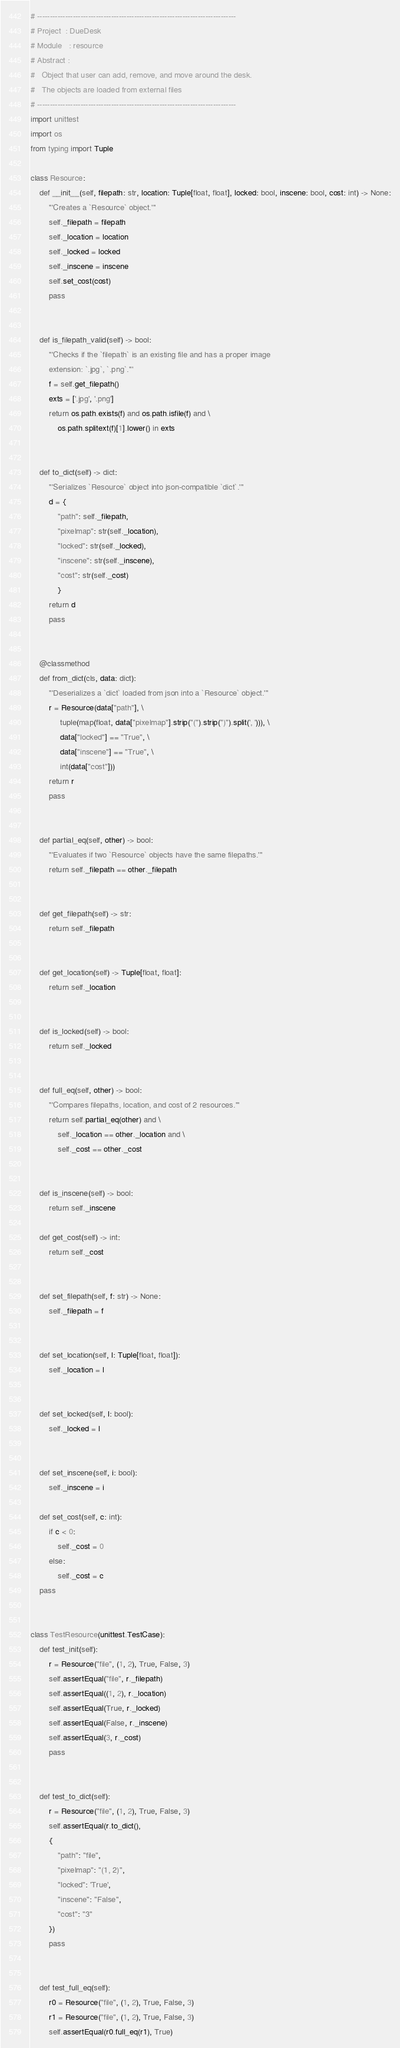<code> <loc_0><loc_0><loc_500><loc_500><_Python_># ------------------------------------------------------------------------------
# Project  : DueDesk
# Module   : resource
# Abstract : 
#   Object that user can add, remove, and move around the desk.
#   The objects are loaded from external files
# ------------------------------------------------------------------------------
import unittest
import os
from typing import Tuple

class Resource:
    def __init__(self, filepath: str, location: Tuple[float, float], locked: bool, inscene: bool, cost: int) -> None:
        '''Creates a `Resource` object.'''
        self._filepath = filepath
        self._location = location
        self._locked = locked
        self._inscene = inscene
        self.set_cost(cost)
        pass


    def is_filepath_valid(self) -> bool:
        '''Checks if the `filepath` is an existing file and has a proper image 
        extension: `.jpg`, `.png`.'''
        f = self.get_filepath()
        exts = ['.jpg', '.png']
        return os.path.exists(f) and os.path.isfile(f) and \
            os.path.splitext(f)[1].lower() in exts


    def to_dict(self) -> dict:
        '''Serializes `Resource` object into json-compatible `dict`.'''
        d = {
            "path": self._filepath, 
            "pixelmap": str(self._location), 
            "locked": str(self._locked), 
            "inscene": str(self._inscene),
            "cost": str(self._cost)
            }
        return d
        pass


    @classmethod
    def from_dict(cls, data: dict):
        '''Deserializes a `dict` loaded from json into a `Resource` object.'''
        r = Resource(data["path"], \
             tuple(map(float, data["pixelmap"].strip("(").strip(")").split(', '))), \
             data["locked"] == "True", \
             data["inscene"] == "True", \
             int(data["cost"]))
        return r
        pass

      
    def partial_eq(self, other) -> bool:
        '''Evaluates if two `Resource` objects have the same filepaths.'''
        return self._filepath == other._filepath
      

    def get_filepath(self) -> str:
        return self._filepath


    def get_location(self) -> Tuple[float, float]:
        return self._location


    def is_locked(self) -> bool:
        return self._locked


    def full_eq(self, other) -> bool:
        '''Compares filepaths, location, and cost of 2 resources.'''
        return self.partial_eq(other) and \
            self._location == other._location and \
            self._cost == other._cost
    

    def is_inscene(self) -> bool:
        return self._inscene

    def get_cost(self) -> int:
        return self._cost


    def set_filepath(self, f: str) -> None:
        self._filepath = f


    def set_location(self, l: Tuple[float, float]):
        self._location = l


    def set_locked(self, l: bool):
        self._locked = l


    def set_inscene(self, i: bool):
        self._inscene = i

    def set_cost(self, c: int):
        if c < 0:
            self._cost = 0
        else:
            self._cost = c
    pass


class TestResource(unittest.TestCase): 
    def test_init(self):
        r = Resource("file", (1, 2), True, False, 3)
        self.assertEqual("file", r._filepath)
        self.assertEqual((1, 2), r._location)
        self.assertEqual(True, r._locked)
        self.assertEqual(False, r._inscene)
        self.assertEqual(3, r._cost)
        pass


    def test_to_dict(self):
        r = Resource("file", (1, 2), True, False, 3)
        self.assertEqual(r.to_dict(), 
        {
            "path": "file", 
            "pixelmap": "(1, 2)", 
            "locked": 'True', 
            "inscene": "False",
            "cost": "3"
        })
        pass
    
    
    def test_full_eq(self):
        r0 = Resource("file", (1, 2), True, False, 3)
        r1 = Resource("file", (1, 2), True, False, 3)
        self.assertEqual(r0.full_eq(r1), True)</code> 